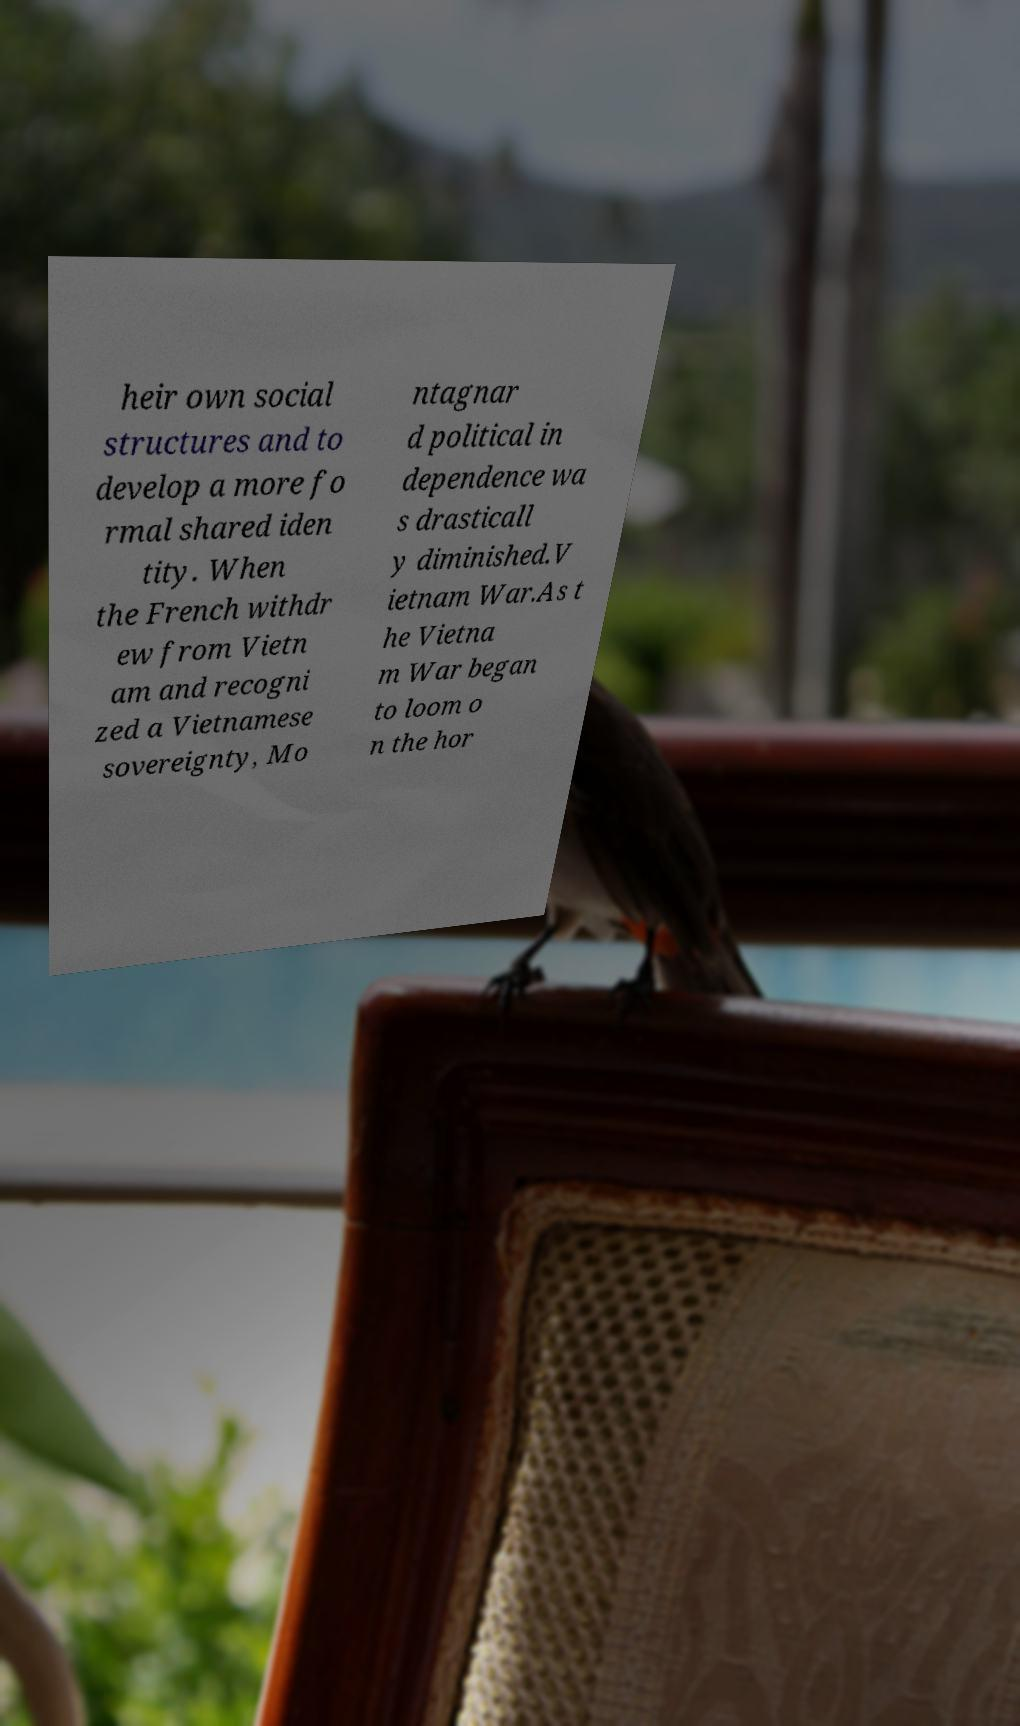Can you accurately transcribe the text from the provided image for me? heir own social structures and to develop a more fo rmal shared iden tity. When the French withdr ew from Vietn am and recogni zed a Vietnamese sovereignty, Mo ntagnar d political in dependence wa s drasticall y diminished.V ietnam War.As t he Vietna m War began to loom o n the hor 